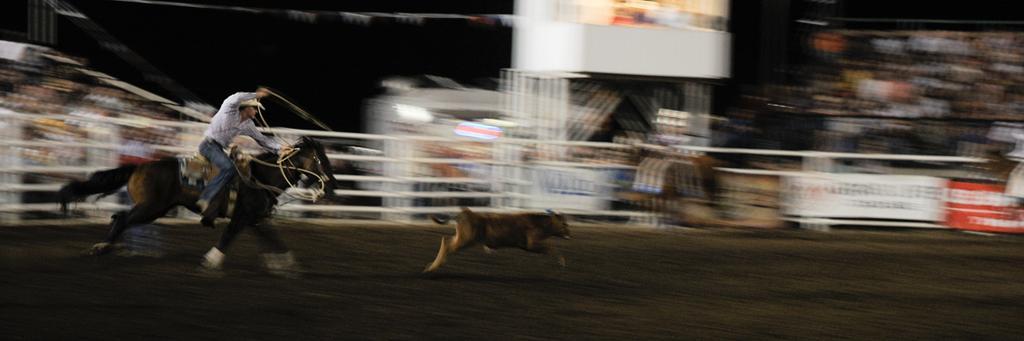Please provide a concise description of this image. This is a blur image. On the left side of the image we can see a man is riding a horse and hunting an animal. In the background of the image we can see the railing, boards, lights. On the boards we can see the text. At the bottom of the image we can see the road. 